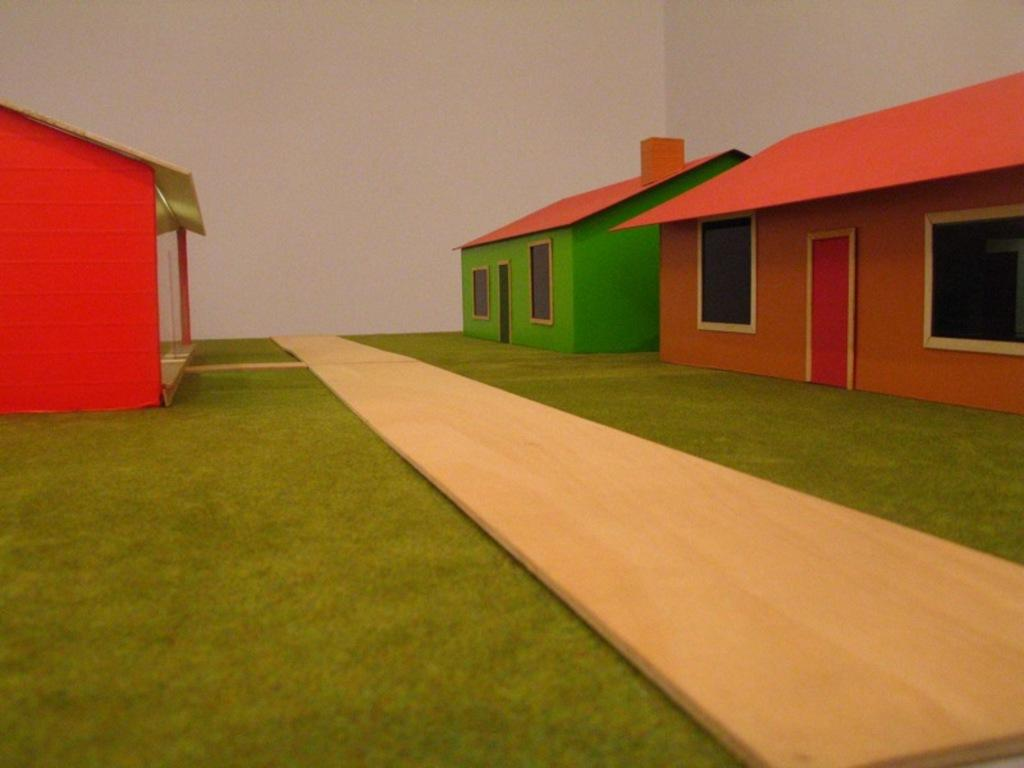What type of objects are featured in the image? There are scale models of houses in the image. Where are the scale models located? The scale models are placed on a surface. What can be seen in the background of the image? There is a wall in the background of the image. How many pigs are visible in the image? There are no pigs present in the image. What type of house is shown in the image? The image features scale models of houses, not a full-sized house. 